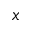Convert formula to latex. <formula><loc_0><loc_0><loc_500><loc_500>x</formula> 